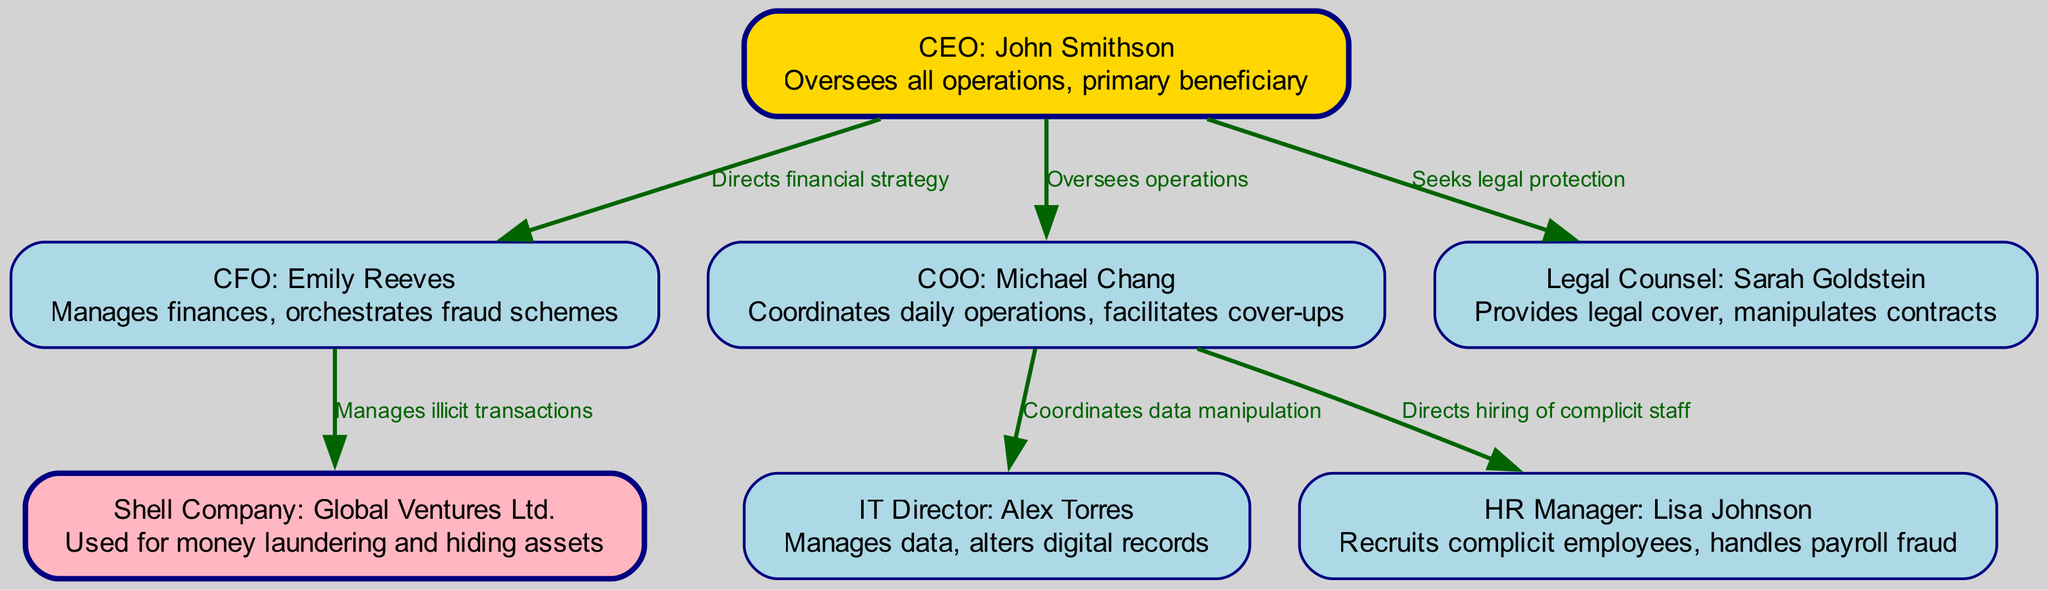What is the title of the CEO? The diagram shows a node labeled "CEO: John Smithson." This indicates that the title of the CEO is John Smithson.
Answer: John Smithson How many key personnel are depicted in the diagram? There are 6 nodes representing key personnel in the diagram: CEO, CFO, COO, Legal Counsel, IT Director, and HR Manager.
Answer: 6 What is the primary role of the CFO? According to the description in the diagram, the CFO manages finances and orchestrates fraud schemes.
Answer: Manages finances, orchestrates fraud schemes Which position coordinates data manipulation? The edge from COO to IT indicates that the COO coordinates data manipulation by connecting with the IT Director.
Answer: COO Who does the CEO seek legal protection from? The edge from CEO to Legal Counsel shows that the CEO seeks protection from the legal counsel, specifically Sarah Goldstein.
Answer: Legal Counsel What color is the node representing the shell company? The diagram indicates that the shell company node is filled with light pink color.
Answer: Light pink How many edges connect to the COO? There are 3 edges connecting to the COO: to IT, HR, and the CEO, thus accommodating the connections from these roles.
Answer: 3 Which role is directly responsible for managing illicit transactions? The CFO is specifically tasked with managing illicit transactions as indicated by the edge connecting CFO to the Shell Company node.
Answer: CFO What is the relationship between the COO and HR Manager? The edge from COO to HR indicates that the COO directs the hiring of complicit staff in relation to the HR Manager.
Answer: Directs hiring of complicit staff What does the Shell Company symbolize in the organizational structure? The shell company, identified as Global Ventures Ltd., is used for money laundering and hiding assets according to the description associated with that node.
Answer: Money laundering and hiding assets 